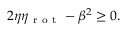Convert formula to latex. <formula><loc_0><loc_0><loc_500><loc_500>2 \eta \eta _ { r o t } - \beta ^ { 2 } \geq 0 .</formula> 